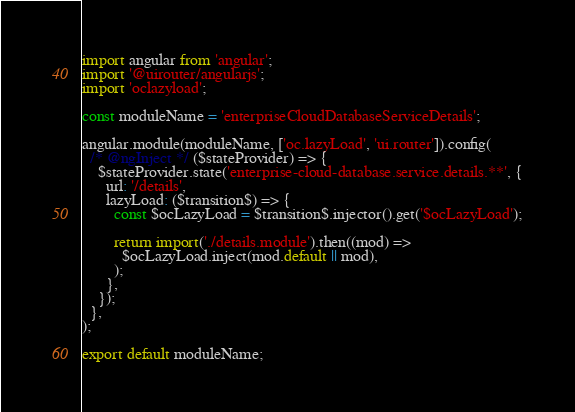Convert code to text. <code><loc_0><loc_0><loc_500><loc_500><_JavaScript_>import angular from 'angular';
import '@uirouter/angularjs';
import 'oclazyload';

const moduleName = 'enterpriseCloudDatabaseServiceDetails';

angular.module(moduleName, ['oc.lazyLoad', 'ui.router']).config(
  /* @ngInject */ ($stateProvider) => {
    $stateProvider.state('enterprise-cloud-database.service.details.**', {
      url: '/details',
      lazyLoad: ($transition$) => {
        const $ocLazyLoad = $transition$.injector().get('$ocLazyLoad');

        return import('./details.module').then((mod) =>
          $ocLazyLoad.inject(mod.default || mod),
        );
      },
    });
  },
);

export default moduleName;
</code> 